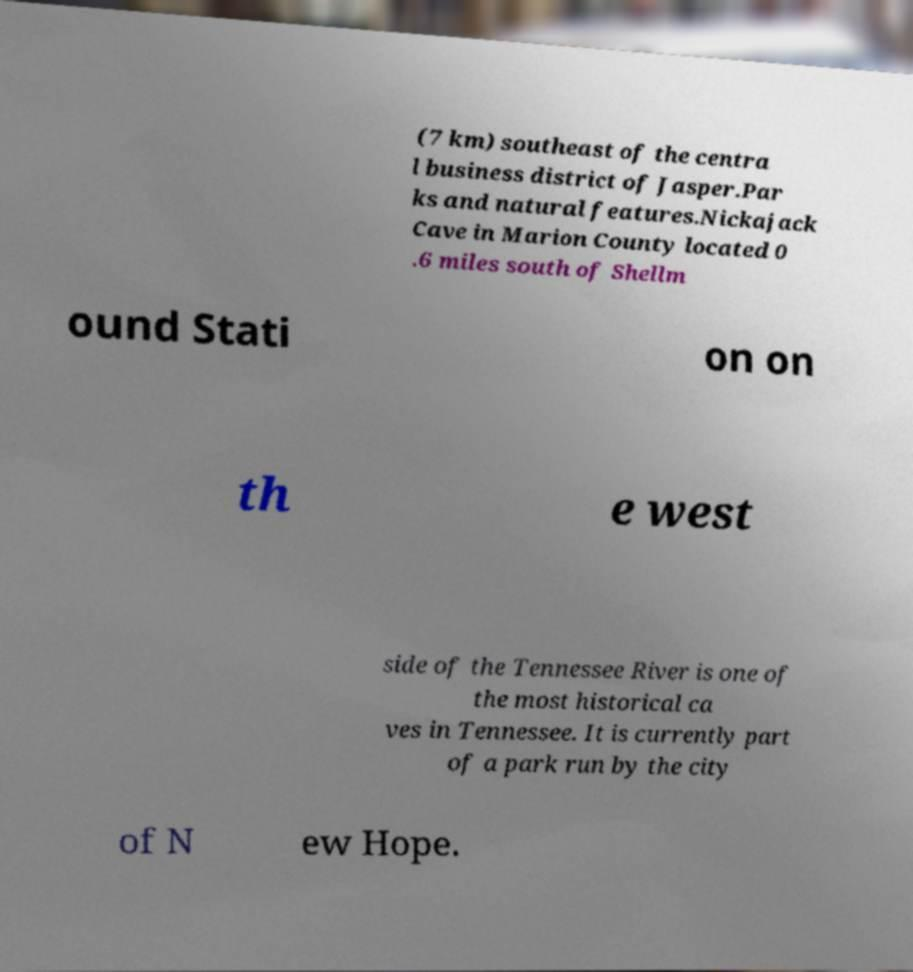Please identify and transcribe the text found in this image. (7 km) southeast of the centra l business district of Jasper.Par ks and natural features.Nickajack Cave in Marion County located 0 .6 miles south of Shellm ound Stati on on th e west side of the Tennessee River is one of the most historical ca ves in Tennessee. It is currently part of a park run by the city of N ew Hope. 